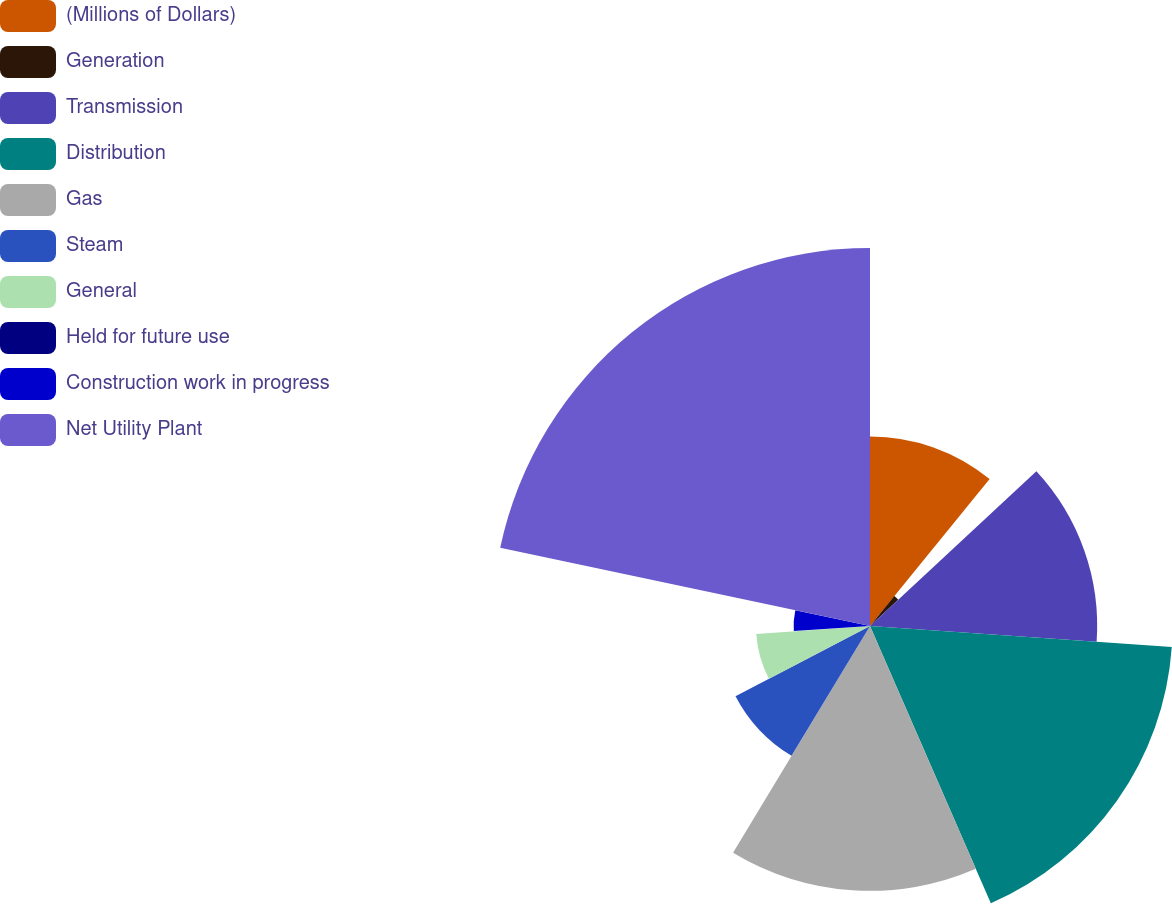<chart> <loc_0><loc_0><loc_500><loc_500><pie_chart><fcel>(Millions of Dollars)<fcel>Generation<fcel>Transmission<fcel>Distribution<fcel>Gas<fcel>Steam<fcel>General<fcel>Held for future use<fcel>Construction work in progress<fcel>Net Utility Plant<nl><fcel>10.87%<fcel>2.21%<fcel>13.03%<fcel>17.35%<fcel>15.19%<fcel>8.7%<fcel>6.54%<fcel>0.05%<fcel>4.38%<fcel>21.68%<nl></chart> 